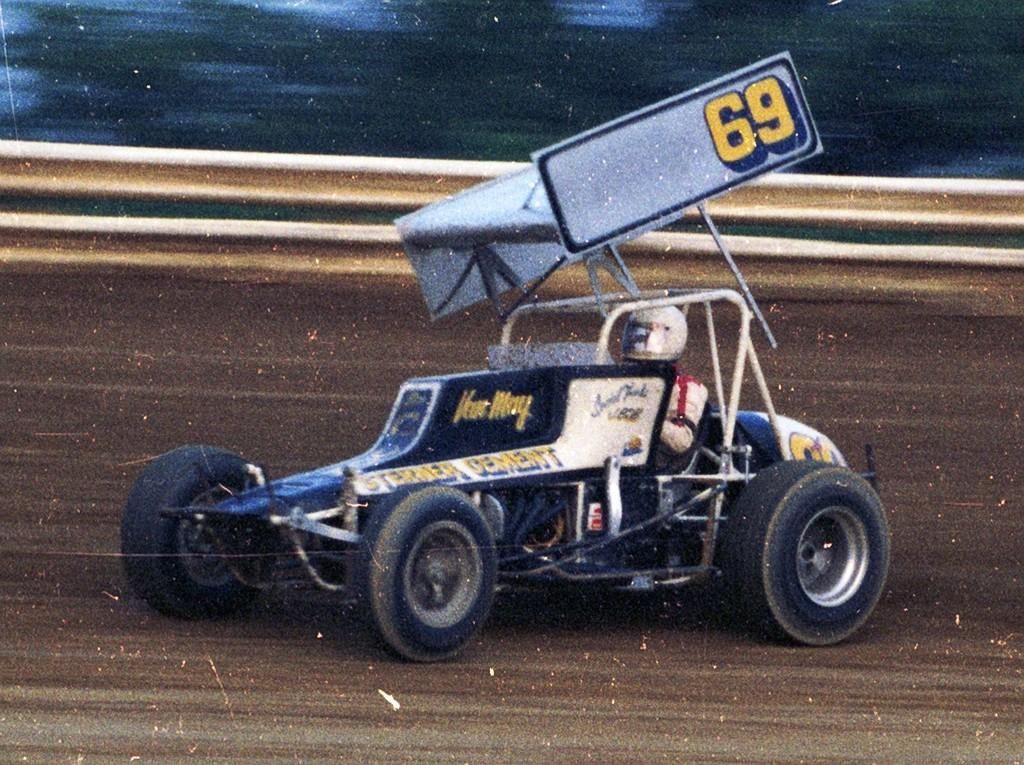Provide a one-sentence caption for the provided image. A picture of a go kart displaying the number 69. 